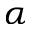Convert formula to latex. <formula><loc_0><loc_0><loc_500><loc_500>\alpha</formula> 